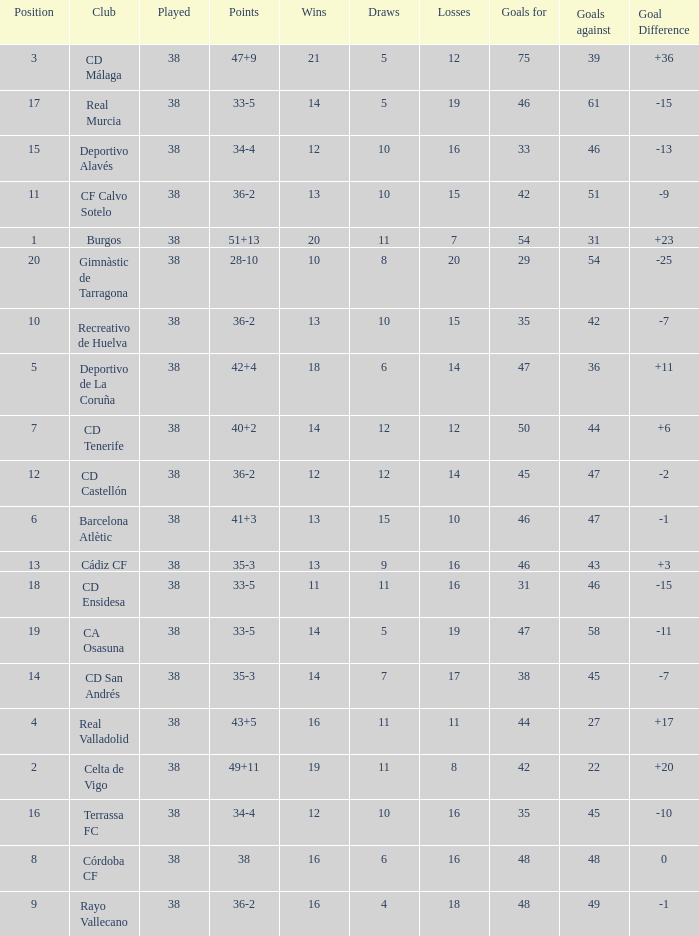What is the average loss with a goal higher than 51 and wins higher than 14? None. 